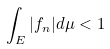Convert formula to latex. <formula><loc_0><loc_0><loc_500><loc_500>\int _ { E } | f _ { n } | d \mu < 1</formula> 